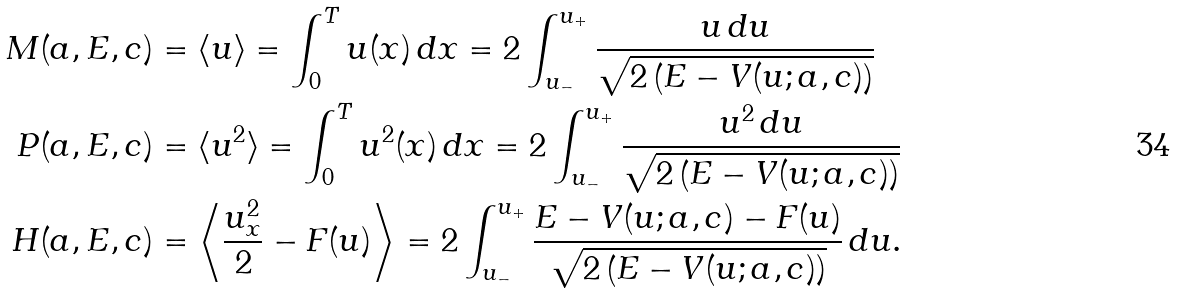<formula> <loc_0><loc_0><loc_500><loc_500>M ( a , E , c ) & = \langle u \rangle = \int _ { 0 } ^ { T } u ( x ) \, d x = 2 \int _ { u _ { - } } ^ { u _ { + } } \frac { u \, d u } { \sqrt { 2 \left ( E - V ( u ; a , c ) \right ) } } \\ P ( a , E , c ) & = \langle u ^ { 2 } \rangle = \int _ { 0 } ^ { T } u ^ { 2 } ( x ) \, d x = 2 \int _ { u _ { - } } ^ { u _ { + } } \frac { u ^ { 2 } \, d u } { \sqrt { 2 \left ( E - V ( u ; a , c ) \right ) } } \\ H ( a , E , c ) & = \left \langle \frac { u _ { x } ^ { 2 } } { 2 } - F ( u ) \right \rangle = 2 \int _ { u _ { - } } ^ { u _ { + } } \frac { E - V ( u ; a , c ) - F ( u ) } { \sqrt { 2 \left ( E - V ( u ; a , c ) \right ) } } \, d u .</formula> 